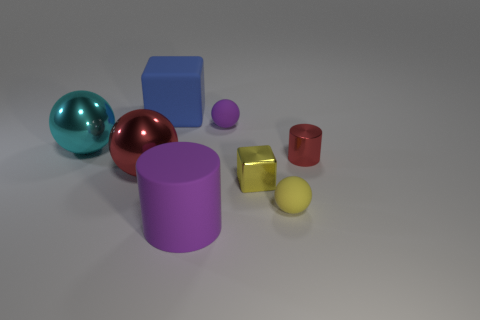Is there a tiny yellow metal object of the same shape as the cyan metal object?
Offer a very short reply. No. What shape is the purple matte object behind the purple object that is in front of the cyan shiny ball?
Offer a very short reply. Sphere. What shape is the small shiny thing to the left of the tiny shiny cylinder?
Offer a terse response. Cube. There is a cube to the left of the rubber cylinder; is it the same color as the tiny ball that is behind the big cyan shiny thing?
Give a very brief answer. No. What number of things are both behind the big red metallic sphere and on the left side of the yellow ball?
Your answer should be compact. 3. The yellow object that is the same material as the red sphere is what size?
Keep it short and to the point. Small. The yellow metal thing is what size?
Your answer should be compact. Small. What material is the tiny red object?
Give a very brief answer. Metal. There is a red thing that is left of the purple matte cylinder; does it have the same size as the small yellow matte thing?
Provide a short and direct response. No. How many objects are red cylinders or tiny yellow metal blocks?
Give a very brief answer. 2. 